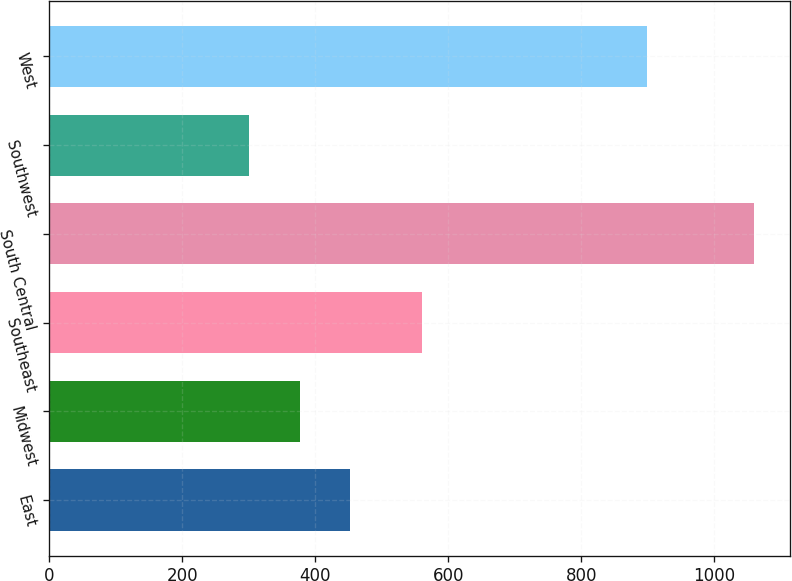Convert chart to OTSL. <chart><loc_0><loc_0><loc_500><loc_500><bar_chart><fcel>East<fcel>Midwest<fcel>Southeast<fcel>South Central<fcel>Southwest<fcel>West<nl><fcel>452.28<fcel>376.24<fcel>560.8<fcel>1060.6<fcel>300.2<fcel>899.6<nl></chart> 